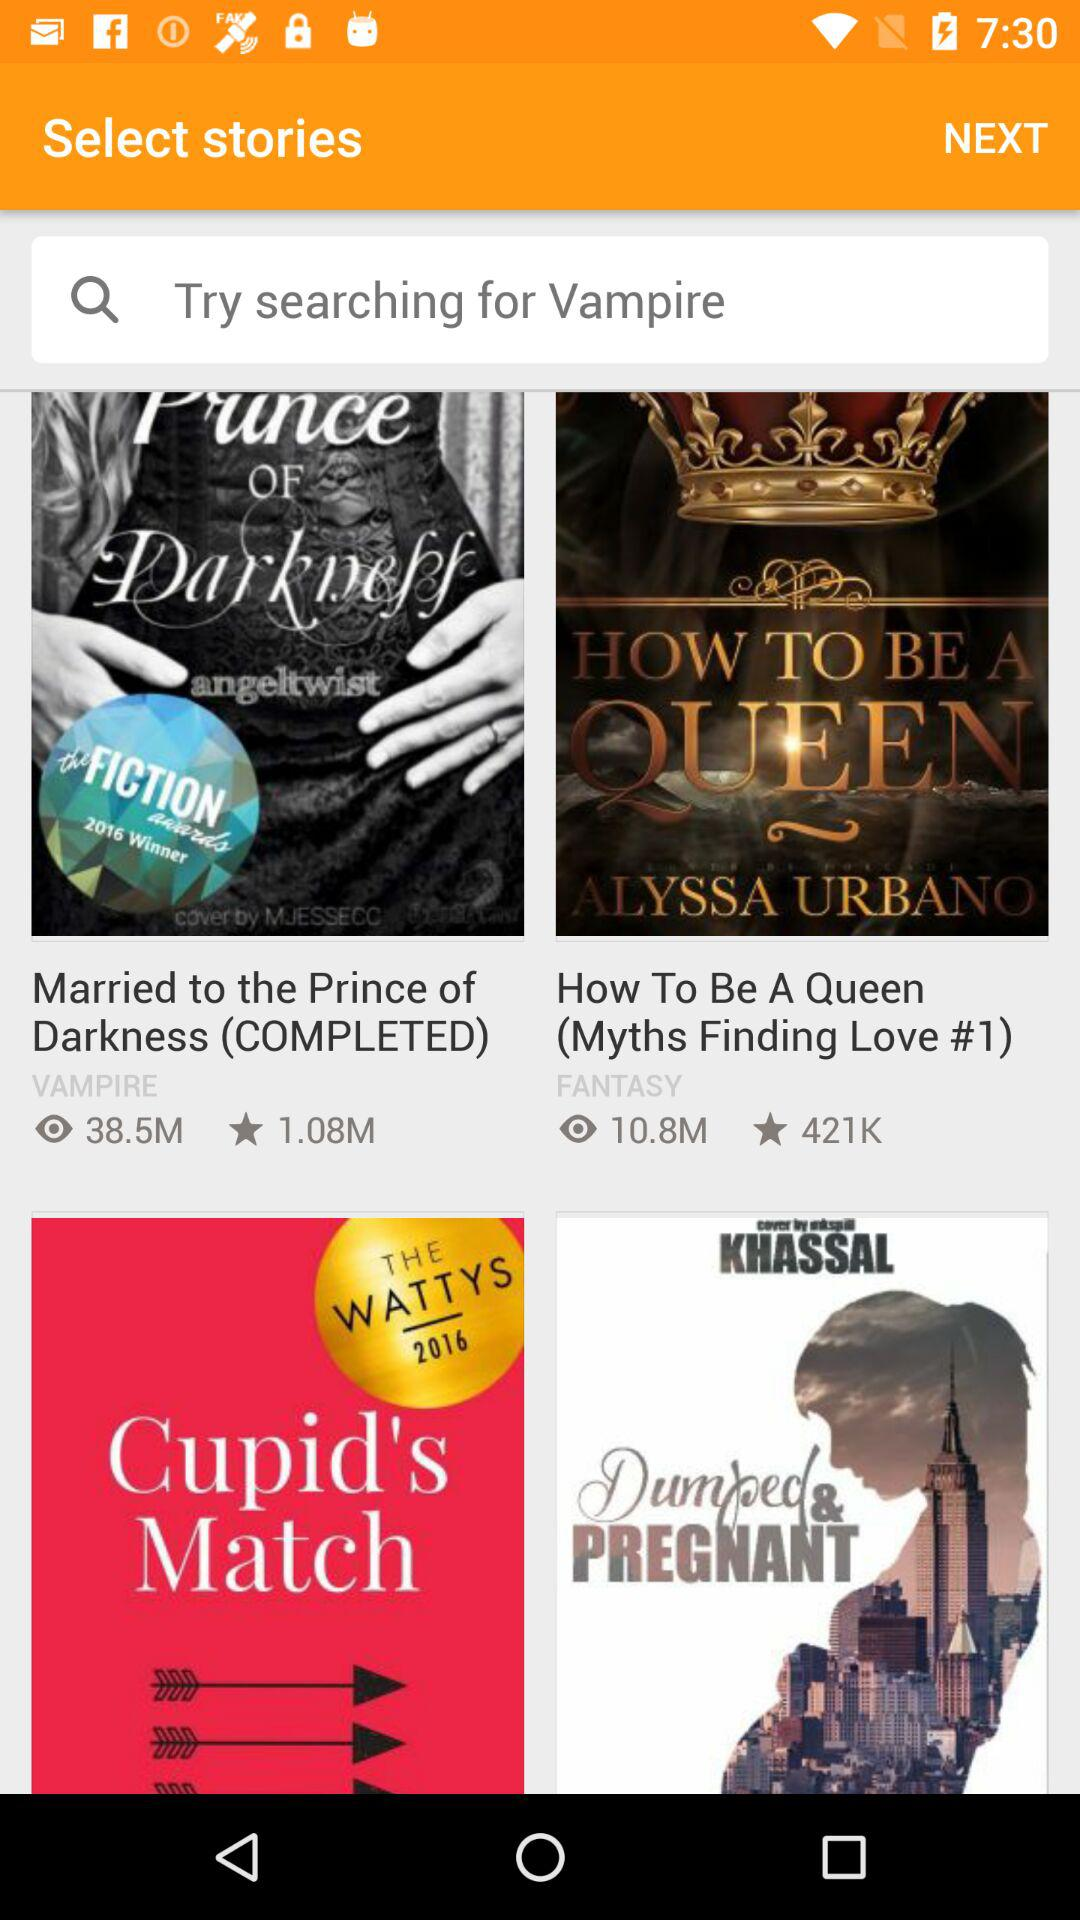What's the genre of the "Married to the Prince of Darkness" story? The genre is "VAMPIRE". 